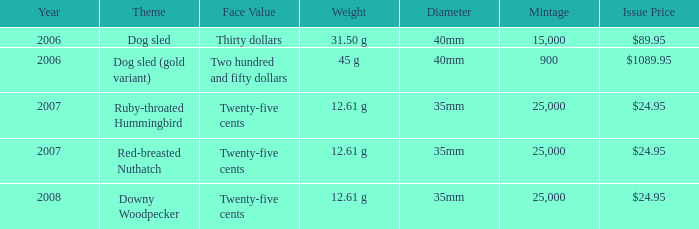What year does a coin with a mintage under 900 and an issue price of $1089.95 belong to? None. 